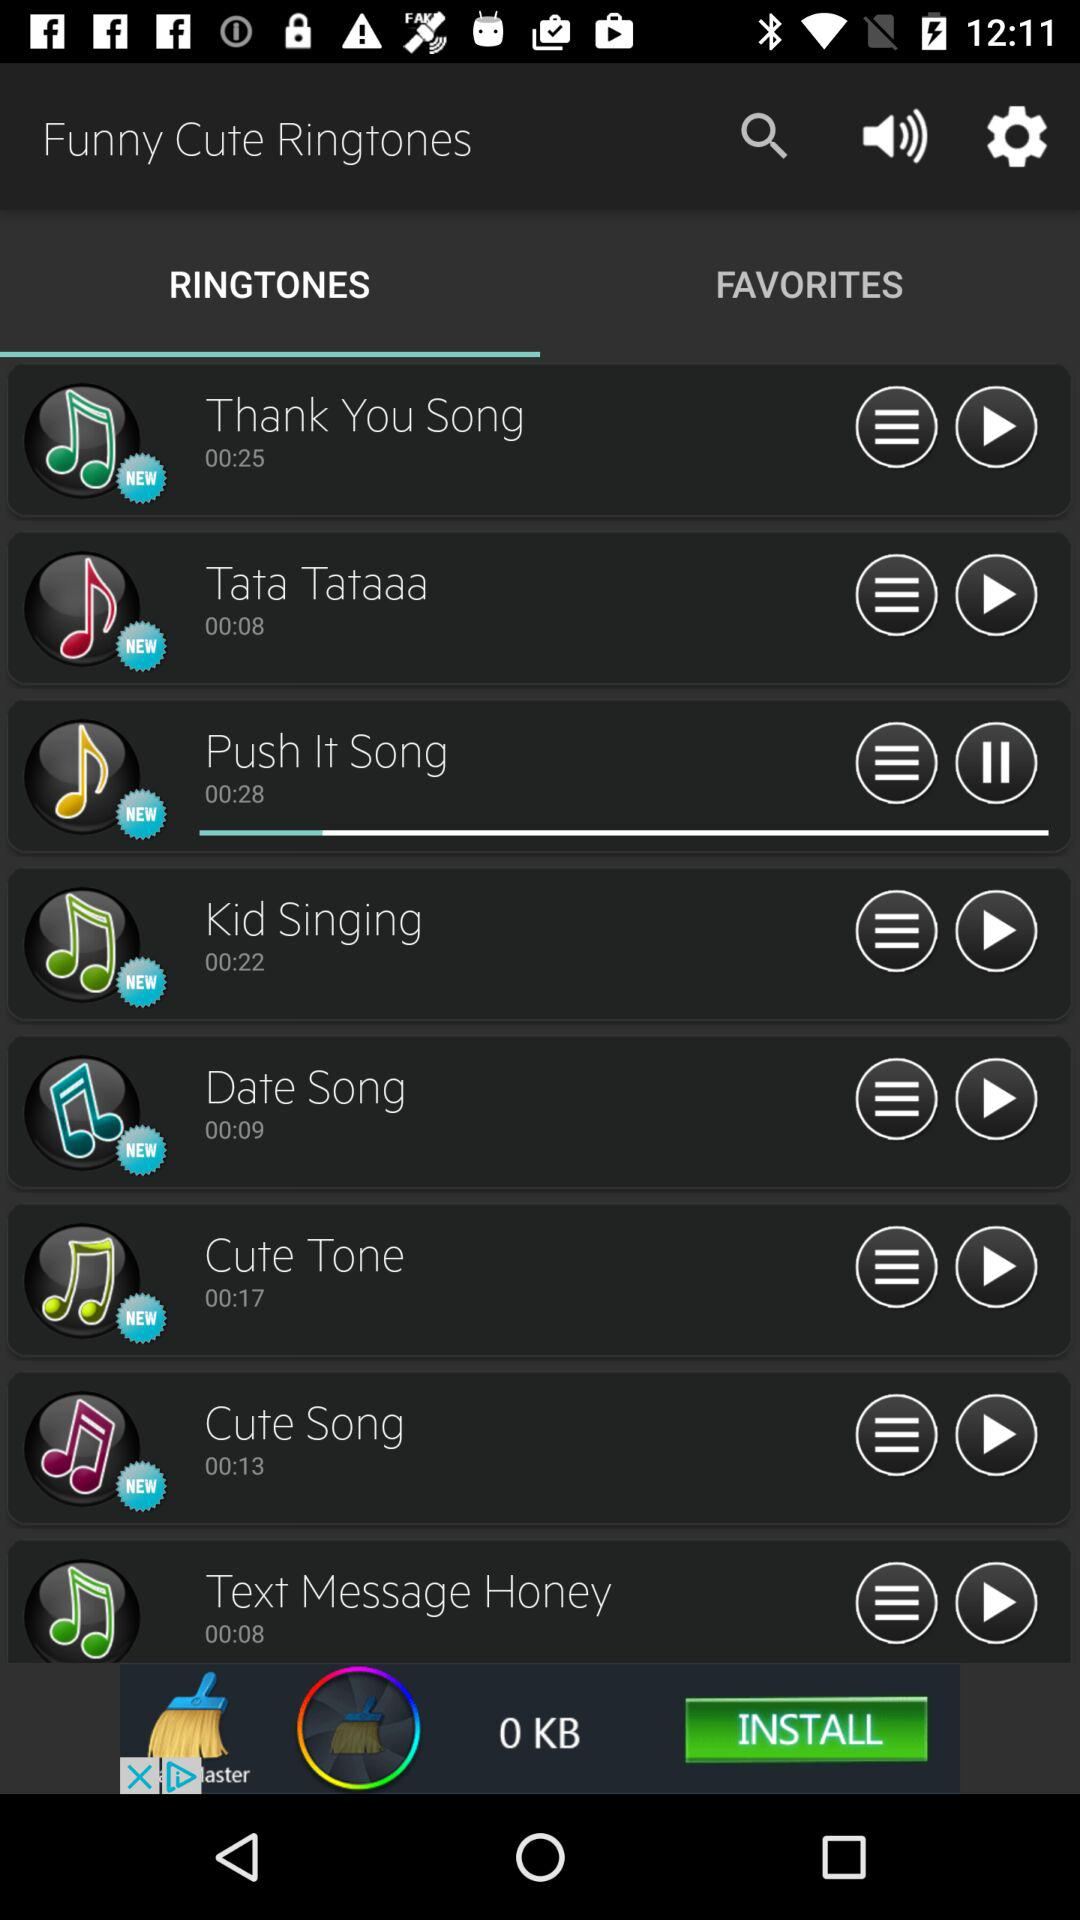What is the time duration of the played ringtone? The time duration is 00:28. 